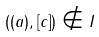<formula> <loc_0><loc_0><loc_500><loc_500>( ( a ) , [ c ] ) \notin I</formula> 